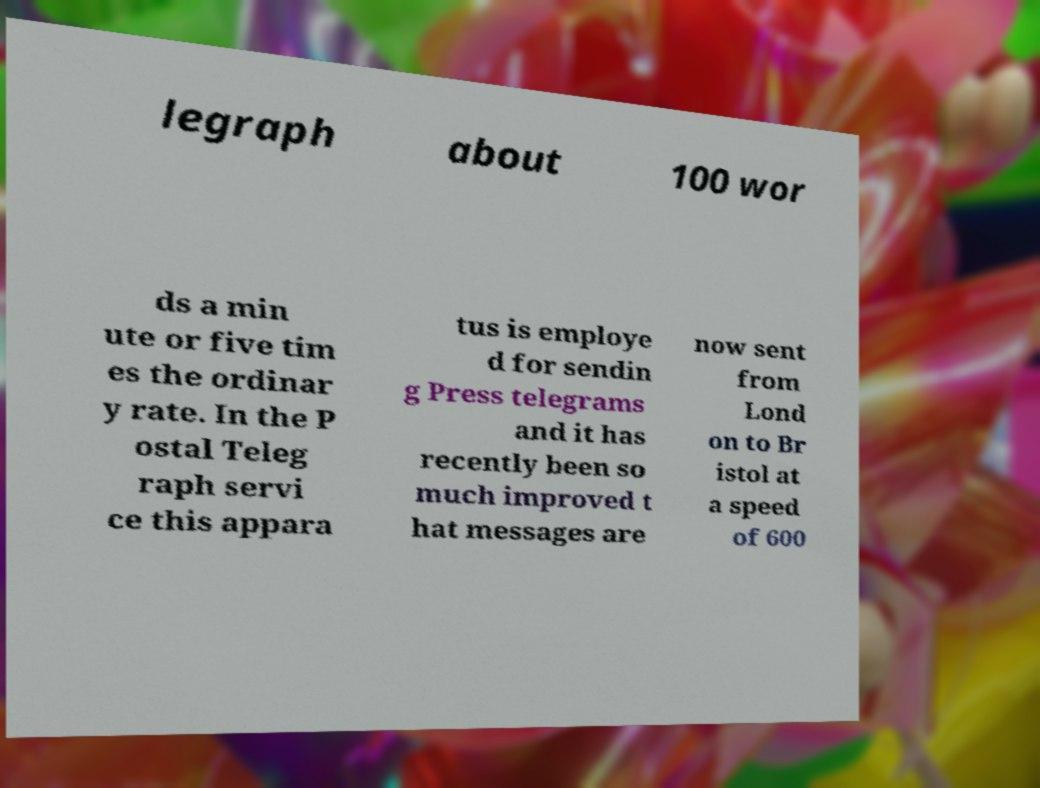There's text embedded in this image that I need extracted. Can you transcribe it verbatim? legraph about 100 wor ds a min ute or five tim es the ordinar y rate. In the P ostal Teleg raph servi ce this appara tus is employe d for sendin g Press telegrams and it has recently been so much improved t hat messages are now sent from Lond on to Br istol at a speed of 600 